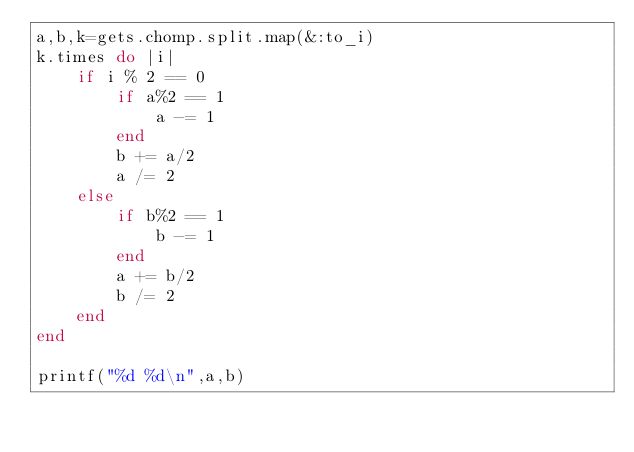<code> <loc_0><loc_0><loc_500><loc_500><_Ruby_>a,b,k=gets.chomp.split.map(&:to_i)
k.times do |i|
    if i % 2 == 0
        if a%2 == 1
            a -= 1
        end
        b += a/2
        a /= 2        
    else
        if b%2 == 1
            b -= 1
        end
        a += b/2
        b /= 2        
    end
end

printf("%d %d\n",a,b)</code> 